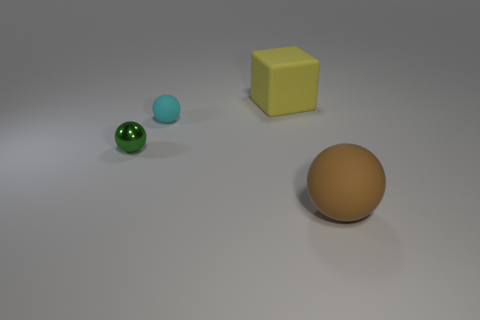Add 1 tiny shiny spheres. How many objects exist? 5 Subtract all balls. How many objects are left? 1 Add 3 large yellow matte cubes. How many large yellow matte cubes exist? 4 Subtract 0 brown cylinders. How many objects are left? 4 Subtract all tiny red cylinders. Subtract all tiny green balls. How many objects are left? 3 Add 3 small shiny things. How many small shiny things are left? 4 